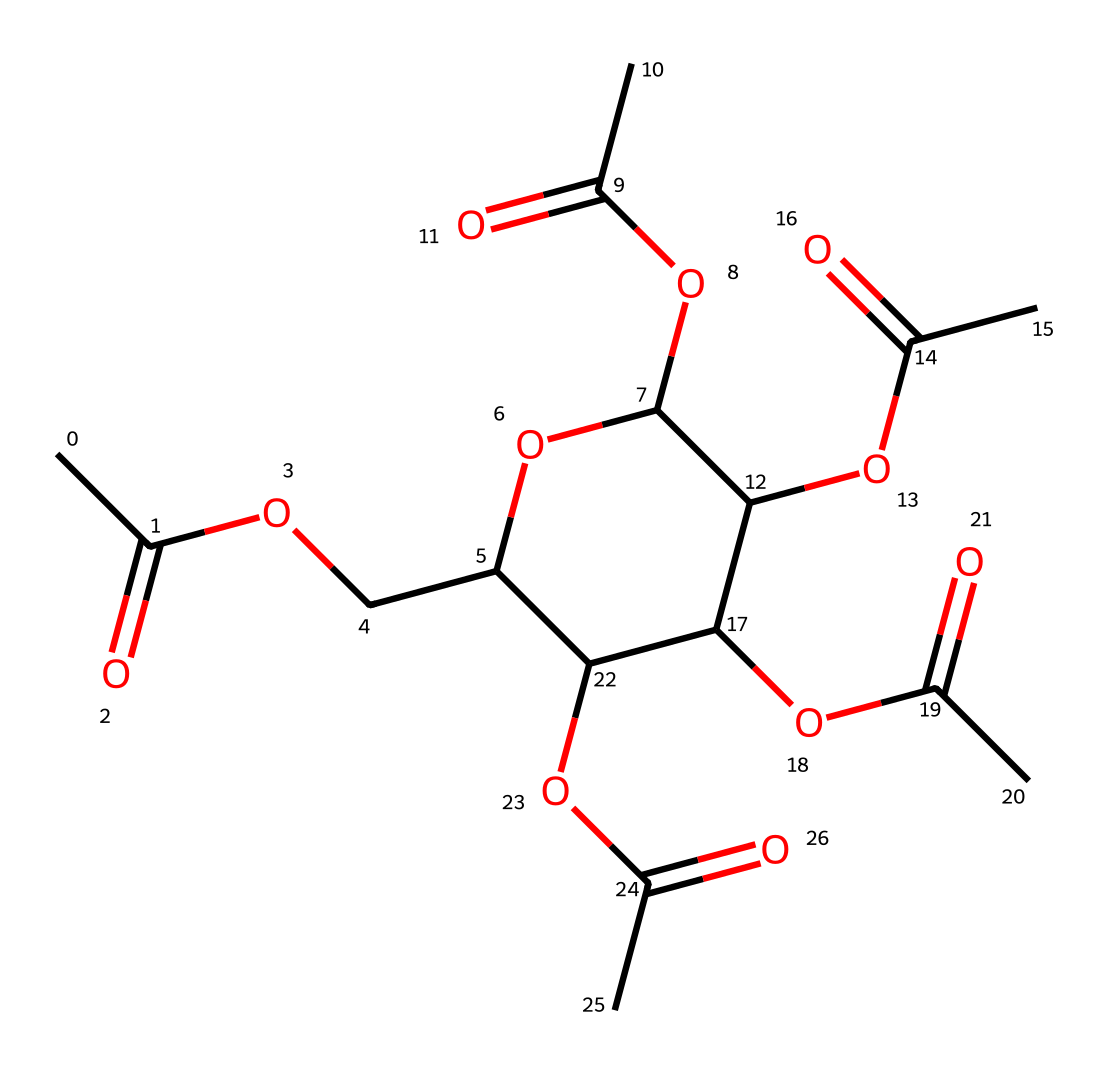What is the primary functional group present in cellulose acetate? The structure features multiple acetyl groups (CC(=O)), which are identified by the carbonyl (C=O) and the attached methyl (C) group. This confirms the presence of the ester functional group.
Answer: ester How many acetate groups are attached to the cellulose backbone? By analyzing the chemical structure, we can count a total of four acetate groups which are represented as OC(C)=O in the structure.
Answer: four What type of polymer is cellulose acetate classified as? The presence of repeating units of acetate and the cellulose backbone suggests that cellulose acetate is a type of polysaccharide where the hydroxyl groups are replaced with acetyl groups.
Answer: polysaccharide How many oxygen atoms are present in the cellulose acetate structure? Counting the atoms in the provided structure reveals a total of 8 oxygen atoms that are part of the functional groups and the ether linkages.
Answer: eight What is the molecular formula of cellulose acetate based on the given SMILES? By evaluating the SMILES representation, one can deduce the complete molecular formula by counting the number of each type of atom present, yielding C12H18O8.
Answer: C12H18O8 Is cellulose acetate soluble in water? The presence of acetyl groups makes cellulose acetate less polar and therefore, it is not highly soluble in water compared to its parent polymer cellulose.
Answer: no 